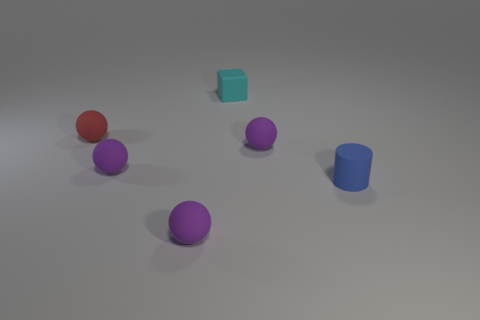What is the material of the small purple ball to the right of the thing behind the red matte thing?
Keep it short and to the point. Rubber. Are there fewer blocks that are in front of the tiny cyan cube than blue objects to the right of the cylinder?
Make the answer very short. No. Are there any other things that have the same shape as the cyan thing?
Offer a very short reply. No. There is a object that is behind the red matte sphere; what material is it?
Offer a terse response. Rubber. Is there anything else that is the same size as the cyan block?
Give a very brief answer. Yes. There is a blue cylinder; are there any blue things behind it?
Provide a short and direct response. No. What is the shape of the small red rubber thing?
Offer a very short reply. Sphere. What number of objects are rubber objects that are behind the tiny red thing or small brown rubber cylinders?
Offer a terse response. 1. Do the small cylinder and the sphere in front of the blue rubber cylinder have the same color?
Give a very brief answer. No. Does the tiny red ball have the same material as the tiny sphere in front of the blue cylinder?
Give a very brief answer. Yes. 